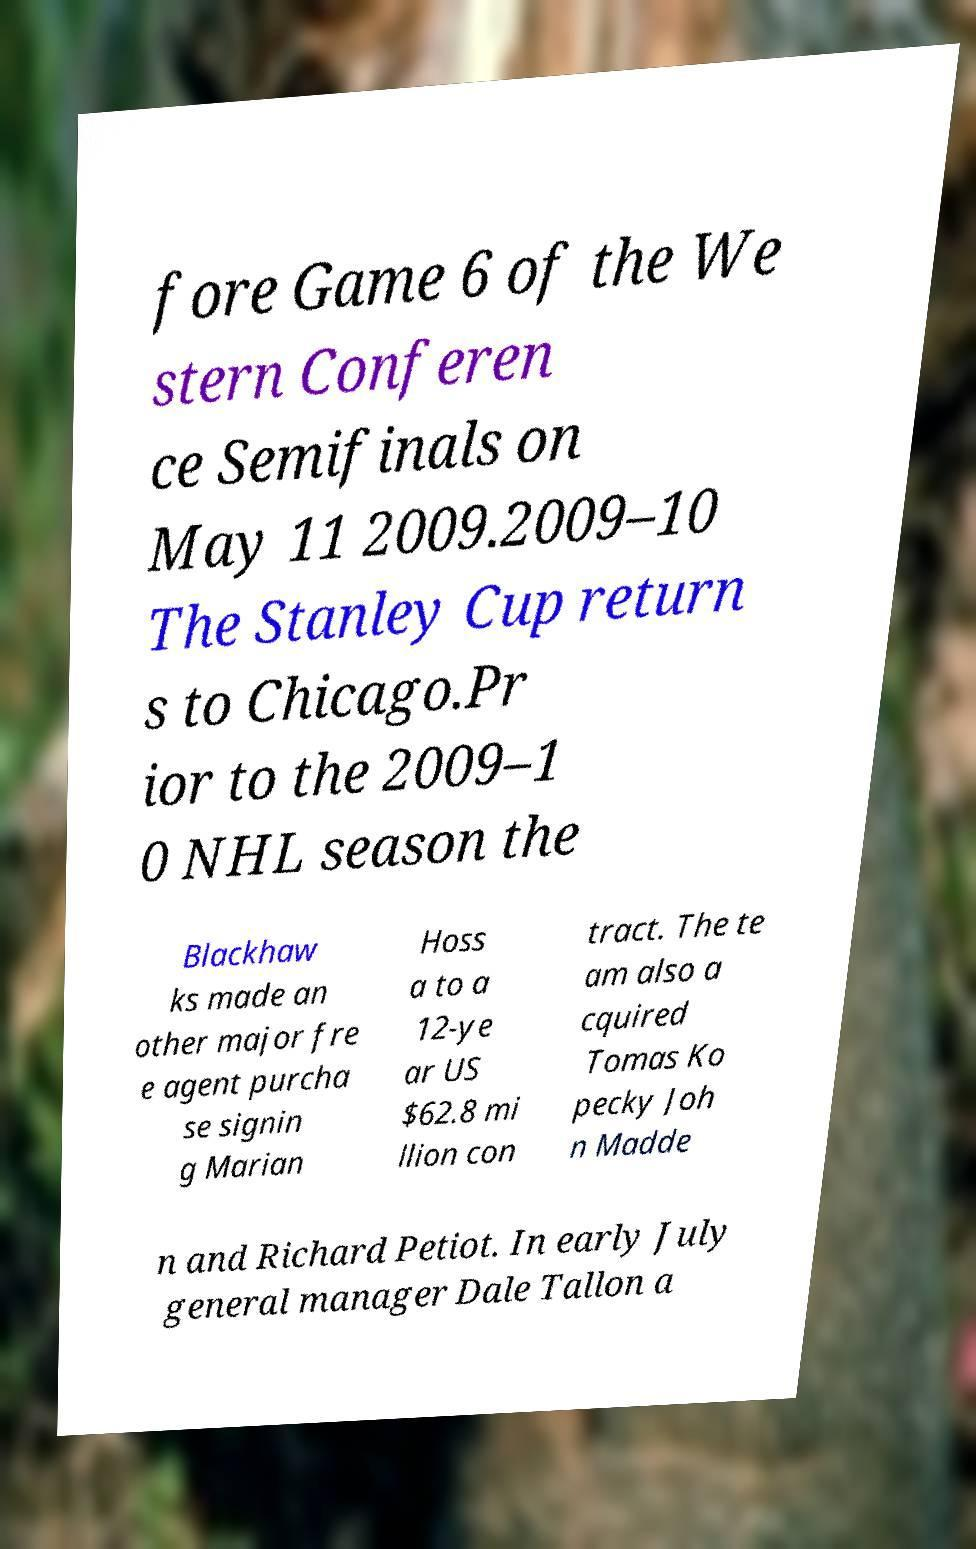Can you accurately transcribe the text from the provided image for me? fore Game 6 of the We stern Conferen ce Semifinals on May 11 2009.2009–10 The Stanley Cup return s to Chicago.Pr ior to the 2009–1 0 NHL season the Blackhaw ks made an other major fre e agent purcha se signin g Marian Hoss a to a 12-ye ar US $62.8 mi llion con tract. The te am also a cquired Tomas Ko pecky Joh n Madde n and Richard Petiot. In early July general manager Dale Tallon a 